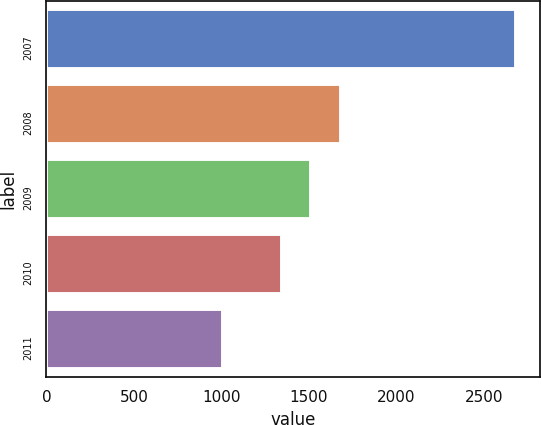<chart> <loc_0><loc_0><loc_500><loc_500><bar_chart><fcel>2007<fcel>2008<fcel>2009<fcel>2010<fcel>2011<nl><fcel>2686<fcel>1682.6<fcel>1514.8<fcel>1347<fcel>1008<nl></chart> 